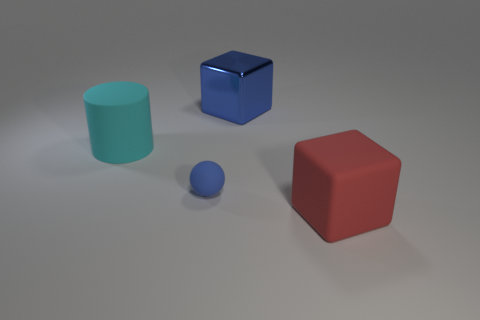What number of blue things are to the right of the large block that is on the left side of the matte thing right of the big metal cube?
Your response must be concise. 0. The block in front of the blue thing that is behind the cyan matte cylinder is what color?
Your answer should be compact. Red. What number of other objects are there of the same material as the blue block?
Provide a succinct answer. 0. What number of small blue balls are on the right side of the blue object behind the large cyan matte object?
Your response must be concise. 0. Is there anything else that is the same shape as the large cyan thing?
Your answer should be very brief. No. There is a large block behind the large cylinder; does it have the same color as the tiny object that is right of the cyan object?
Give a very brief answer. Yes. Is the number of tiny green rubber balls less than the number of big objects?
Offer a terse response. Yes. There is a large rubber object that is left of the blue object behind the cyan thing; what is its shape?
Provide a short and direct response. Cylinder. Is there any other thing that is the same size as the ball?
Your response must be concise. No. What shape is the big matte object that is in front of the large rubber object to the left of the blue object that is behind the big cyan rubber cylinder?
Ensure brevity in your answer.  Cube. 